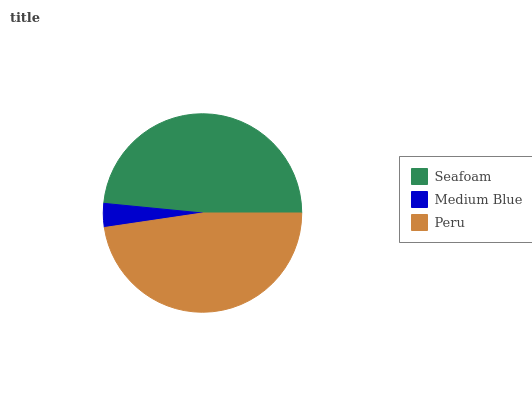Is Medium Blue the minimum?
Answer yes or no. Yes. Is Seafoam the maximum?
Answer yes or no. Yes. Is Peru the minimum?
Answer yes or no. No. Is Peru the maximum?
Answer yes or no. No. Is Peru greater than Medium Blue?
Answer yes or no. Yes. Is Medium Blue less than Peru?
Answer yes or no. Yes. Is Medium Blue greater than Peru?
Answer yes or no. No. Is Peru less than Medium Blue?
Answer yes or no. No. Is Peru the high median?
Answer yes or no. Yes. Is Peru the low median?
Answer yes or no. Yes. Is Seafoam the high median?
Answer yes or no. No. Is Medium Blue the low median?
Answer yes or no. No. 